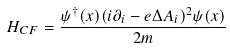Convert formula to latex. <formula><loc_0><loc_0><loc_500><loc_500>H _ { C F } = \frac { \psi ^ { \dag } ( x ) ( i \partial _ { i } - e \Delta A _ { i } ) ^ { 2 } \psi ( x ) } { 2 m }</formula> 